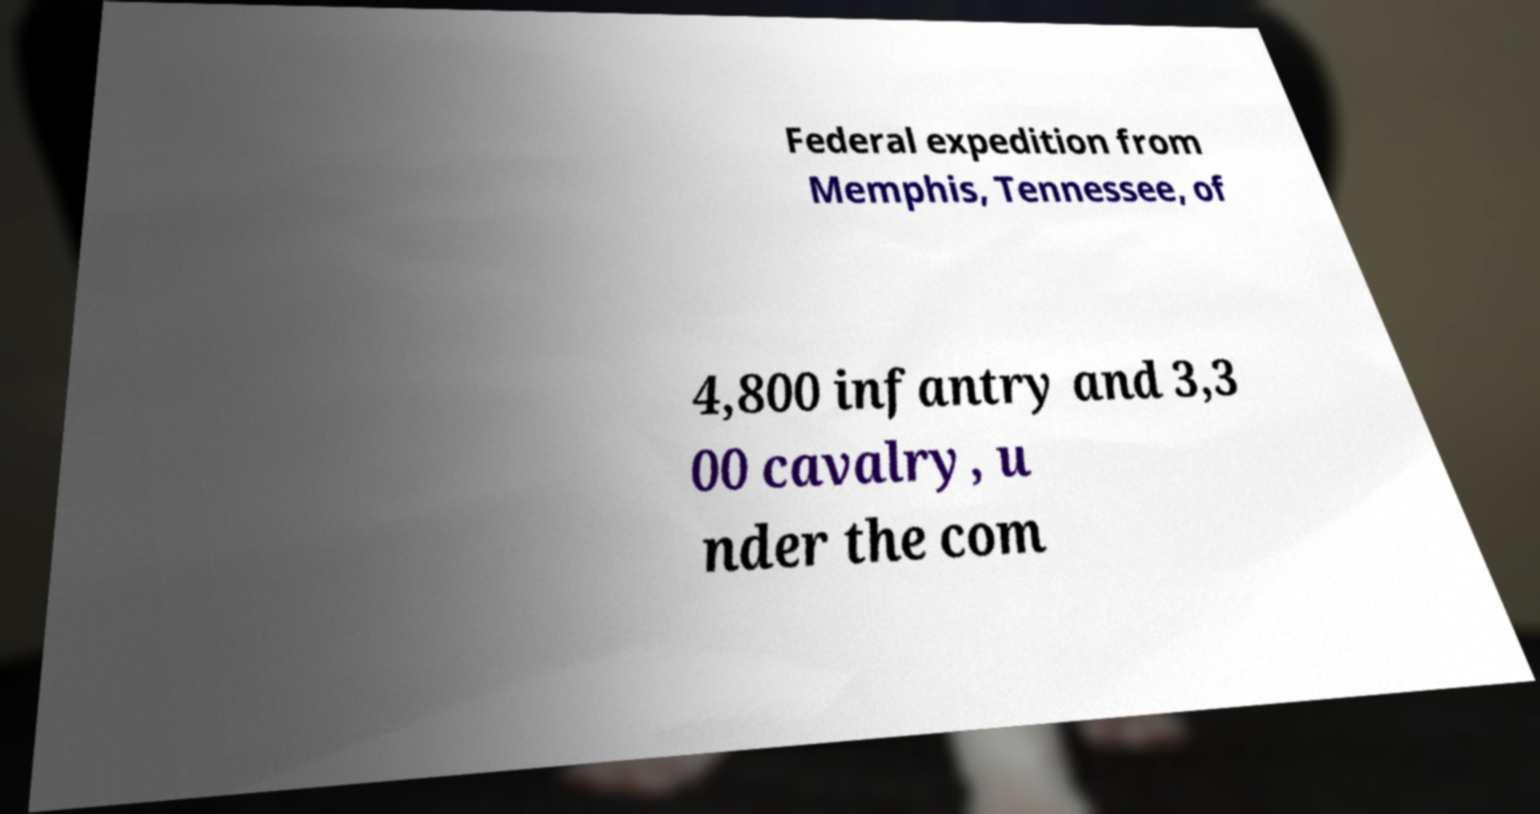There's text embedded in this image that I need extracted. Can you transcribe it verbatim? Federal expedition from Memphis, Tennessee, of 4,800 infantry and 3,3 00 cavalry, u nder the com 